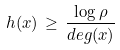Convert formula to latex. <formula><loc_0><loc_0><loc_500><loc_500>h ( x ) \, \geq \, \frac { \log \rho } { d e g ( x ) }</formula> 